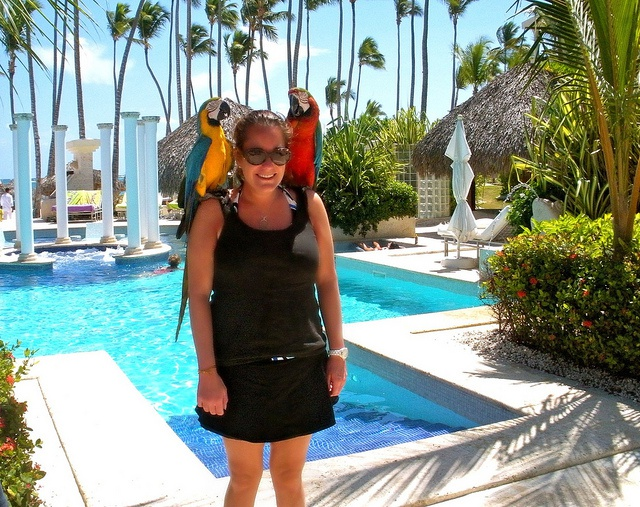Describe the objects in this image and their specific colors. I can see people in olive, black, brown, and maroon tones, bird in olive, black, orange, and teal tones, bird in olive, brown, maroon, and black tones, umbrella in olive, darkgray, lightgray, and lightblue tones, and chair in olive, darkgray, lightgray, and tan tones in this image. 